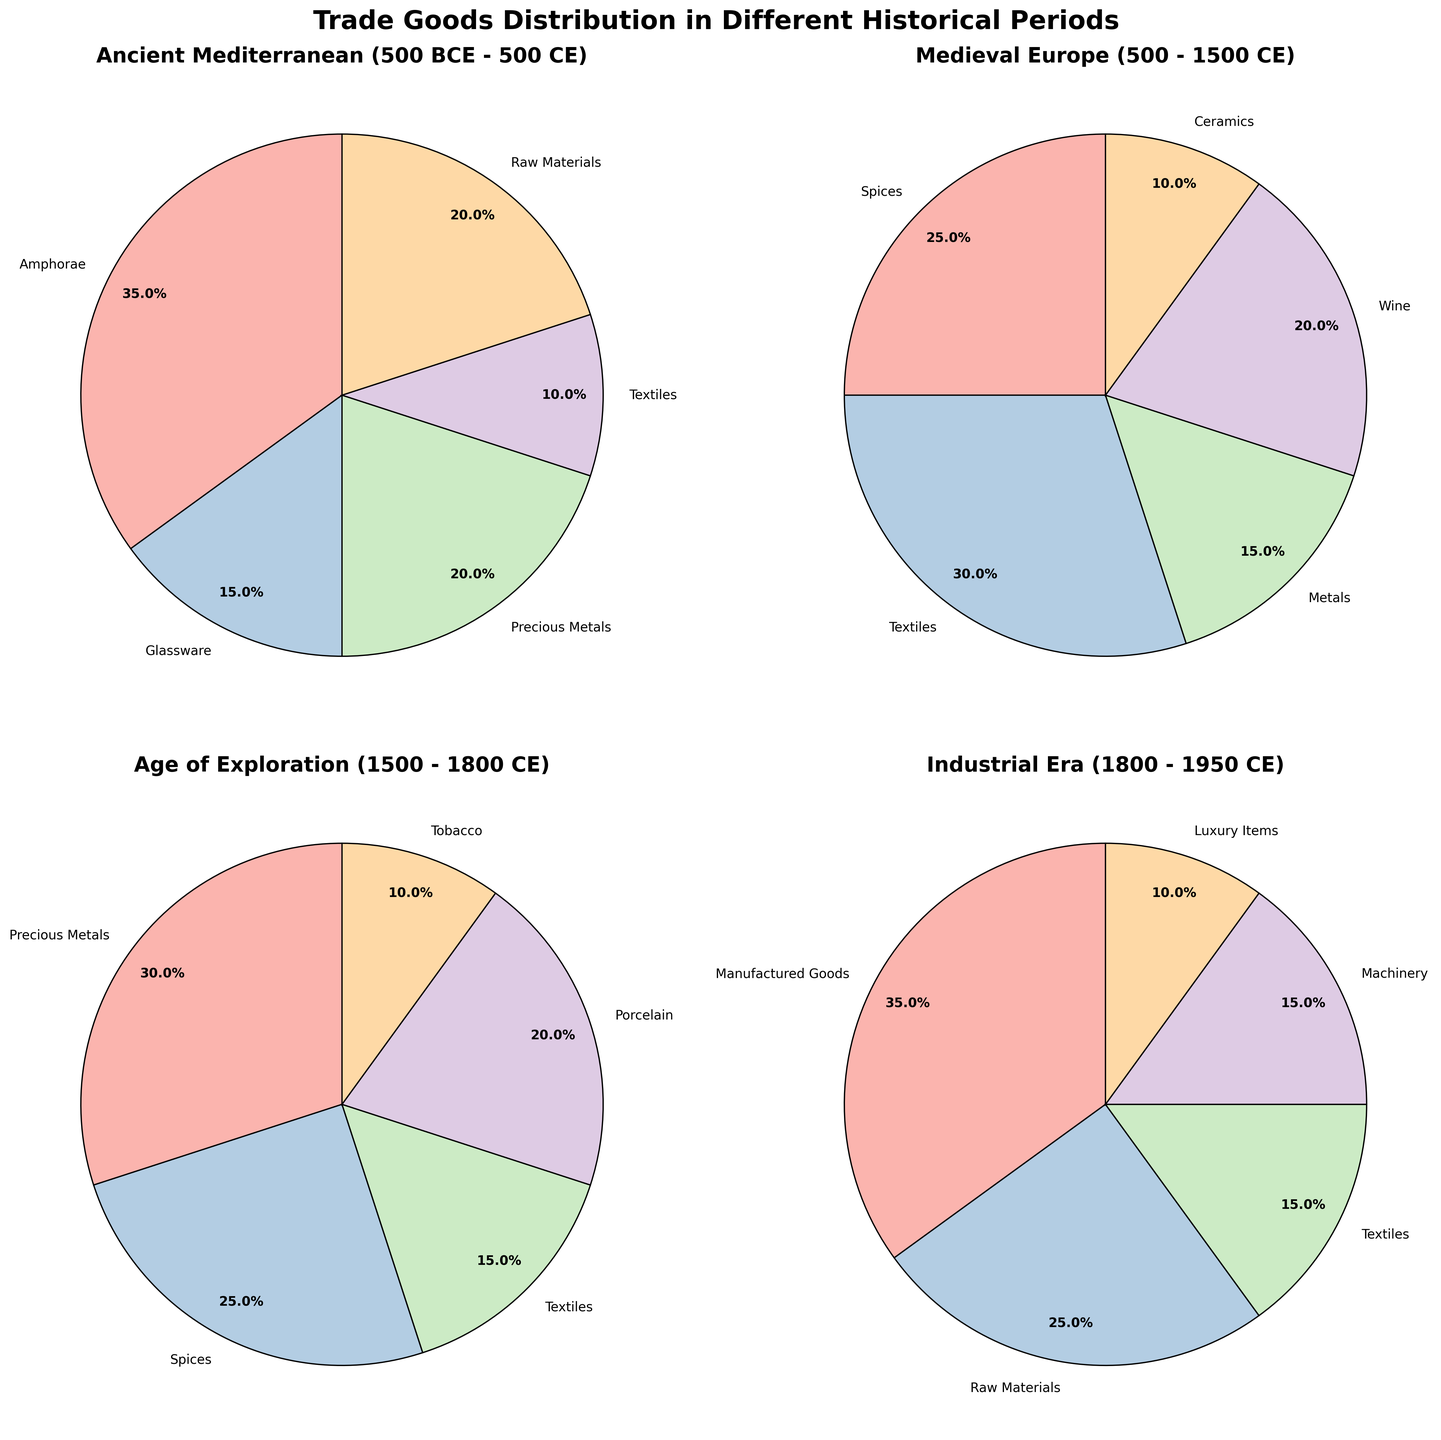How much larger is the percentage of Amphorae than Glassware in the Ancient Mediterranean period? First, find the percentage of Amphorae and Glassware in the Ancient Mediterranean period: Amphorae (35%) and Glassware (15%). Subtract the percentage of Glassware from Amphorae: 35% - 15% = 20%.
Answer: 20% Which historical period has the highest percentage of Precious Metals? Comparing the given periods: Ancient Mediterranean (20%), Medieval Europe (not listed), Age of Exploration (30%), and Industrial Era (not listed). The Age of Exploration has the highest percentage of Precious Metals at 30%.
Answer: Age of Exploration Which two trade goods combined make up 50% of the trade in the Age of Exploration period? The percentages of trade goods in the Age of Exploration period are: Precious Metals (30%), Spices (25%), Textiles (15%), Porcelain (20%), and Tobacco (10%). Check combinations to see which add up to 50%: Precious Metals (30%) + Spices (25%) = 55% (too high), Precious Metals (30%) + Textiles (15%) = 45% (too low), Precious Metals (30%) + Porcelain (20%) = 50%.
Answer: Precious Metals and Porcelain What is the smallest percentage of trade goods by category across all periods, and which good does it represent? Scan the pie charts for the smallest percentage values: Ancient Mediterranean - Textiles (10%), Medieval Europe - Ceramics (10%), Age of Exploration - Tobacco (10%), Industrial Era - Luxury Items (10%). The smallest percentage value is 10%, which is shared by Textiles, Ceramics, Tobacco, and Luxury Items.
Answer: 10%, Textiles, Ceramics, Tobacco, Luxury Items What is the approximate cumulative percentage of Raw Materials across all periods? Find the percentages of Raw Materials: Ancient Mediterranean (20%), and Industrial Era (25%). Sum these percentages: 20% + 25% = 45%.
Answer: 45% In which period does Spices have the highest representation, and what is its percentage? Compare the percentages of Spices in Medieval Europe (25%) and Age of Exploration (25%). Both periods have an equal highest representation of Spices at 25%.
Answer: Medieval Europe, Age of Exploration, 25% Is the percentage of Textiles higher in the Medieval Europe period or the Industrial Era period? The percentage of Textiles in Medieval Europe is 30%, and in the Industrial Era it is 15%. Clearly, 30% is higher than 15%.
Answer: Medieval Europe What is the combined percentage of Manufactured Goods and Machinery in the Industrial Era period? Find the percentages of Manufactured Goods (35%) and Machinery (15%) in the Industrial Era period. Sum these percentages: 35% + 15% = 50%.
Answer: 50% What is the second most prominent trade good in the Ancient Mediterranean period? The percentages of trade goods in the Ancient Mediterranean period are: Amphorae (35%), Glassware (15%), Precious Metals (20%), Textiles (10%), Raw Materials (20%). The second highest is a tie between Precious Metals and Raw Materials at 20%.
Answer: Precious Metals, Raw Materials Which period showcases the highest diversity in trade goods based on the number of distinct categories? Calculate the number of distinct trade goods for each period: Ancient Mediterranean (5), Medieval Europe (5), Age of Exploration (5), Industrial Era (5). All periods show the same diversity with 5 distinct categories each.
Answer: Ancient Mediterranean, Medieval Europe, Age of Exploration, Industrial Era 